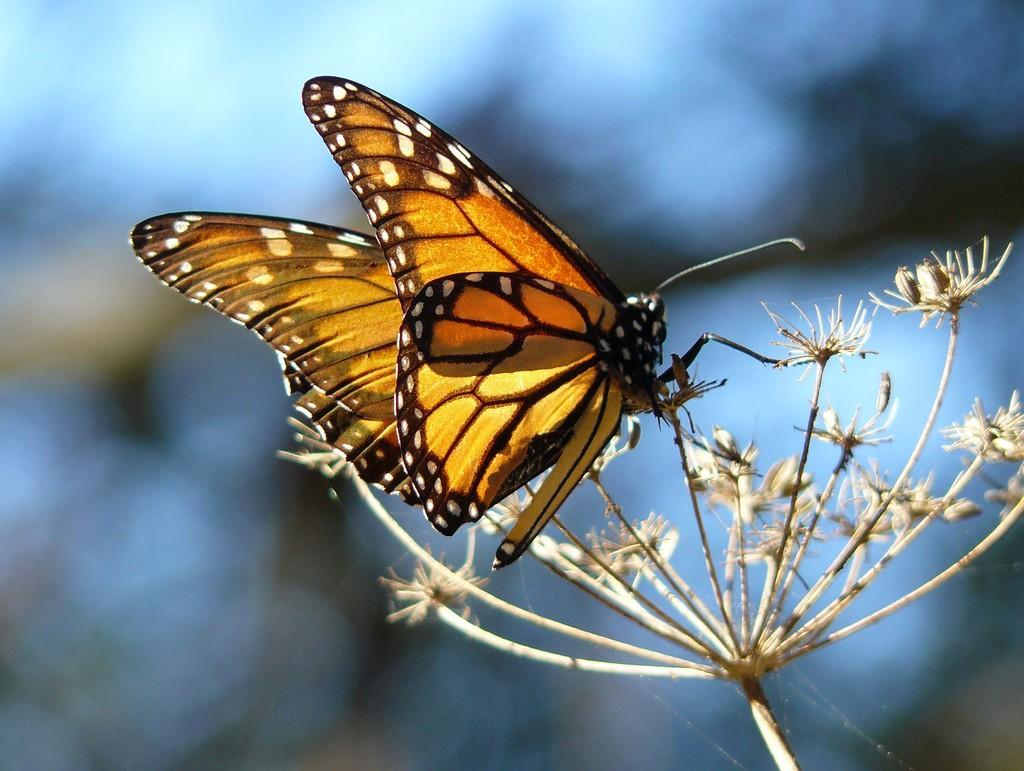Describe this image in one or two sentences. This picture seems to be clicked outside. In the foreground we can see a moth seems to be on the flower like object. The background of the image is blurry. 